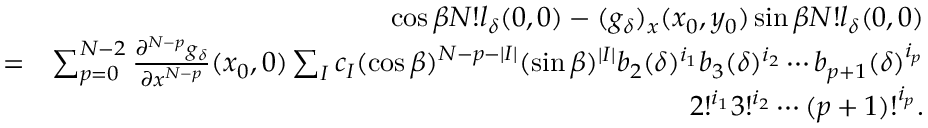Convert formula to latex. <formula><loc_0><loc_0><loc_500><loc_500>\begin{array} { r l r } & { \cos \beta N ! l _ { \delta } ( 0 , 0 ) - ( g _ { \delta } ) _ { x } ( x _ { 0 } , y _ { 0 } ) \sin \beta N ! l _ { \delta } ( 0 , 0 ) } \\ & { = } & { \sum _ { p = 0 } ^ { N - 2 } \frac { \partial ^ { N - p } g _ { \delta } } { \partial x ^ { N - p } } ( x _ { 0 } , 0 ) \sum _ { I } c _ { I } ( \cos \beta ) ^ { N - p - | I | } ( \sin \beta ) ^ { | I | } b _ { 2 } ( \delta ) ^ { i _ { 1 } } b _ { 3 } ( \delta ) ^ { i _ { 2 } } \cdots b _ { p + 1 } ( \delta ) ^ { i _ { p } } } \\ & { 2 ! ^ { i _ { 1 } } 3 ! ^ { i _ { 2 } } \cdots ( p + 1 ) ! ^ { i _ { p } } . } \end{array}</formula> 